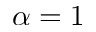<formula> <loc_0><loc_0><loc_500><loc_500>\alpha = 1</formula> 